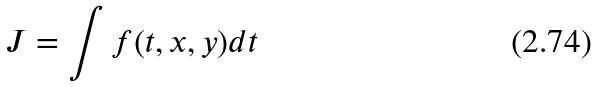Convert formula to latex. <formula><loc_0><loc_0><loc_500><loc_500>J = \int f ( t , x , y ) d t</formula> 